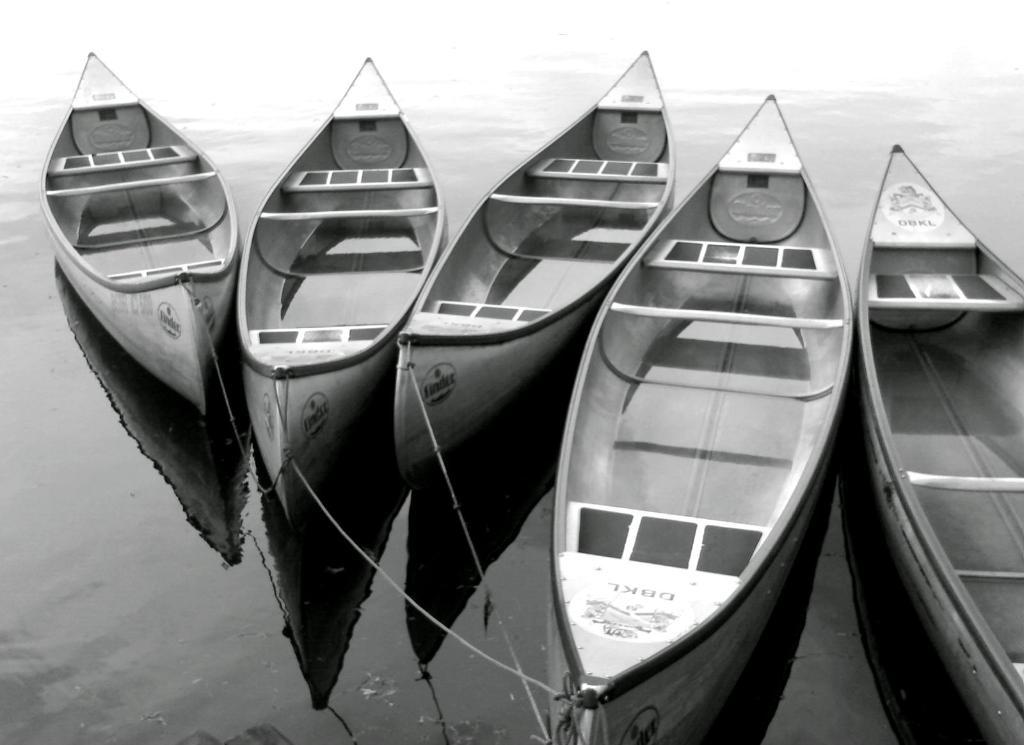What is in the water in the image? There are four boats with threads in the water. Can you describe the position of one of the boats in the image? One boat is partially visible on the right side of the image. What is present on the boats in the image? There is text and images on the boats. What type of crow is sitting on the front of the boat in the image? There is no crow present in the image; it only features boats with threads in the water. How much debt is owed by the boat owner in the image? There is no information about debt in the image, as it only shows boats with threads in the water. 